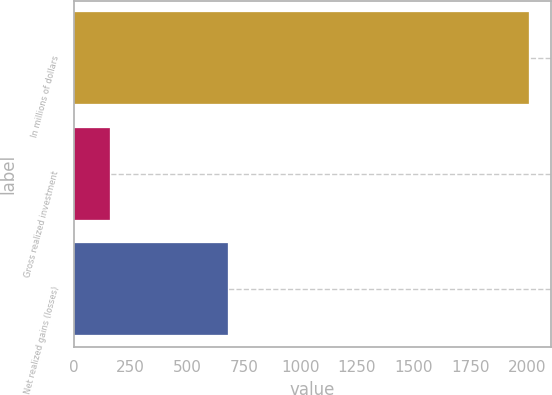<chart> <loc_0><loc_0><loc_500><loc_500><bar_chart><fcel>In millions of dollars<fcel>Gross realized investment<fcel>Net realized gains (losses)<nl><fcel>2008<fcel>158<fcel>679<nl></chart> 